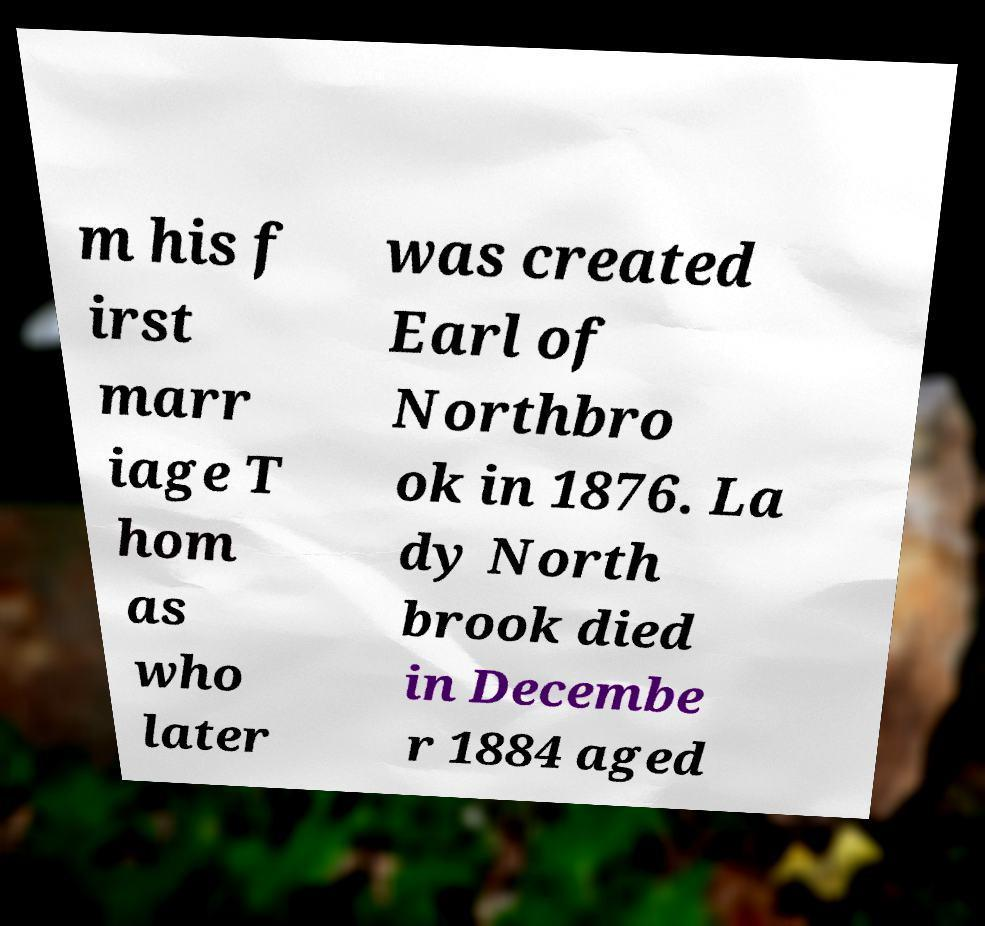Please read and relay the text visible in this image. What does it say? m his f irst marr iage T hom as who later was created Earl of Northbro ok in 1876. La dy North brook died in Decembe r 1884 aged 